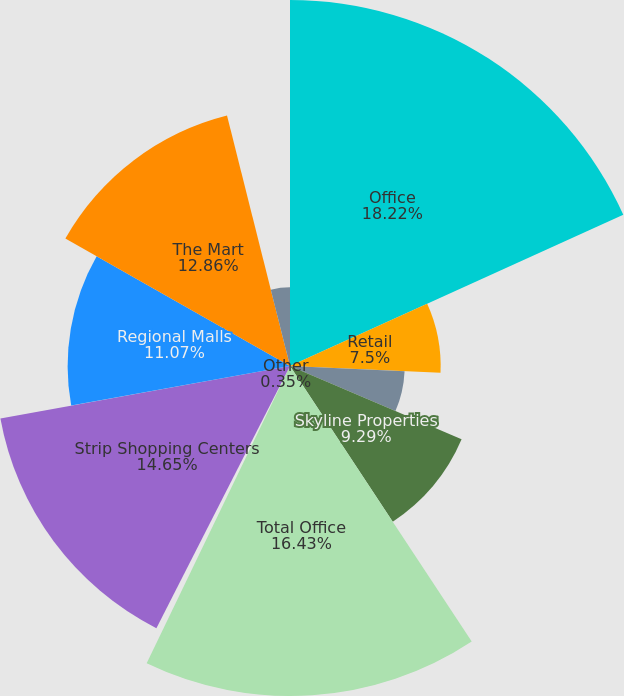Convert chart. <chart><loc_0><loc_0><loc_500><loc_500><pie_chart><fcel>Office<fcel>Retail<fcel>Alexander's<fcel>Skyline Properties<fcel>Total Office<fcel>Other<fcel>Strip Shopping Centers<fcel>Regional Malls<fcel>The Mart<fcel>555 California Street<nl><fcel>18.22%<fcel>7.5%<fcel>5.71%<fcel>9.29%<fcel>16.43%<fcel>0.35%<fcel>14.65%<fcel>11.07%<fcel>12.86%<fcel>3.92%<nl></chart> 